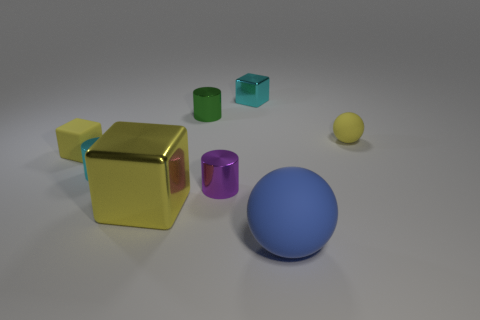How many metal cylinders are there?
Offer a terse response. 3. Are there any metal cubes that have the same color as the small ball?
Keep it short and to the point. Yes. There is a small rubber object to the right of the small yellow object left of the big object that is left of the blue thing; what is its color?
Your answer should be compact. Yellow. Do the small green cylinder and the ball that is right of the big sphere have the same material?
Your response must be concise. No. What is the small purple cylinder made of?
Ensure brevity in your answer.  Metal. There is a block that is the same color as the large metallic object; what material is it?
Ensure brevity in your answer.  Rubber. What number of other objects are there of the same material as the tiny green thing?
Make the answer very short. 4. There is a object that is right of the big metal block and in front of the purple cylinder; what is its shape?
Your answer should be compact. Sphere. There is another block that is the same material as the large yellow block; what color is it?
Offer a terse response. Cyan. Are there the same number of green cylinders that are in front of the big blue ball and big purple metal objects?
Your answer should be very brief. Yes. 